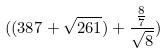Convert formula to latex. <formula><loc_0><loc_0><loc_500><loc_500>( ( 3 8 7 + \sqrt { 2 6 1 } ) + \frac { \frac { 8 } { 7 } } { \sqrt { 8 } } )</formula> 